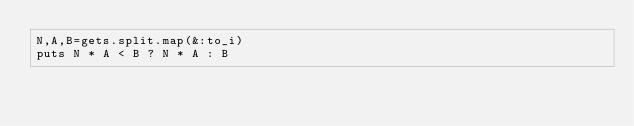Convert code to text. <code><loc_0><loc_0><loc_500><loc_500><_Ruby_>N,A,B=gets.split.map(&:to_i)
puts N * A < B ? N * A : B</code> 